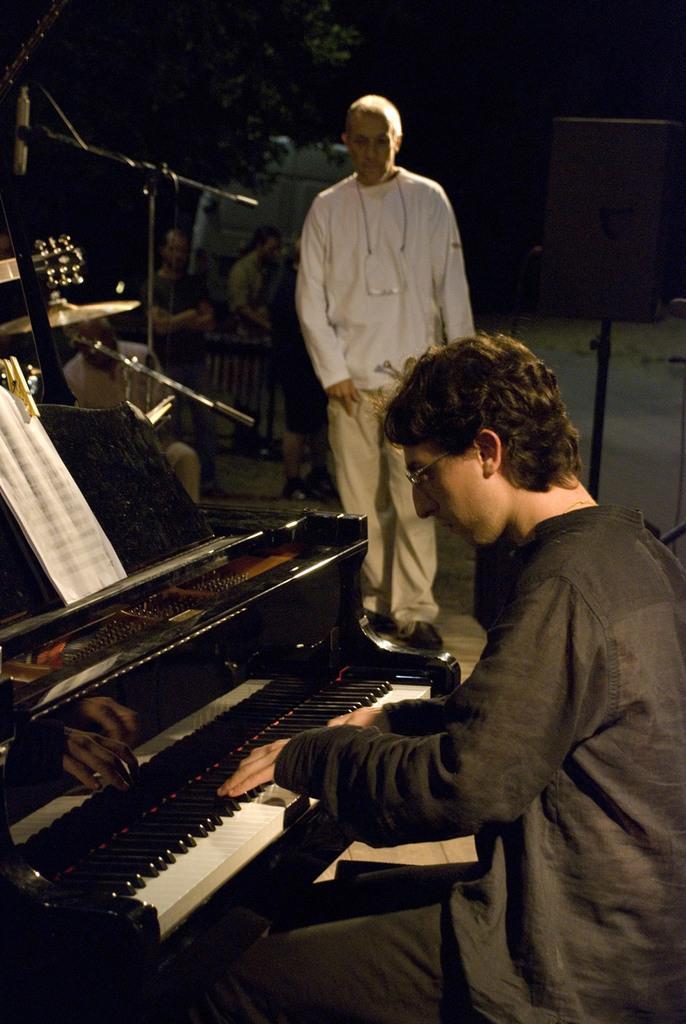In one or two sentences, can you explain what this image depicts? In this image I can see man is playing a piano. And a man standing on the floor. 